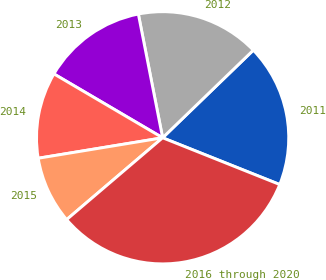Convert chart to OTSL. <chart><loc_0><loc_0><loc_500><loc_500><pie_chart><fcel>2011<fcel>2012<fcel>2013<fcel>2014<fcel>2015<fcel>2016 through 2020<nl><fcel>18.27%<fcel>15.86%<fcel>13.46%<fcel>11.05%<fcel>8.64%<fcel>32.72%<nl></chart> 